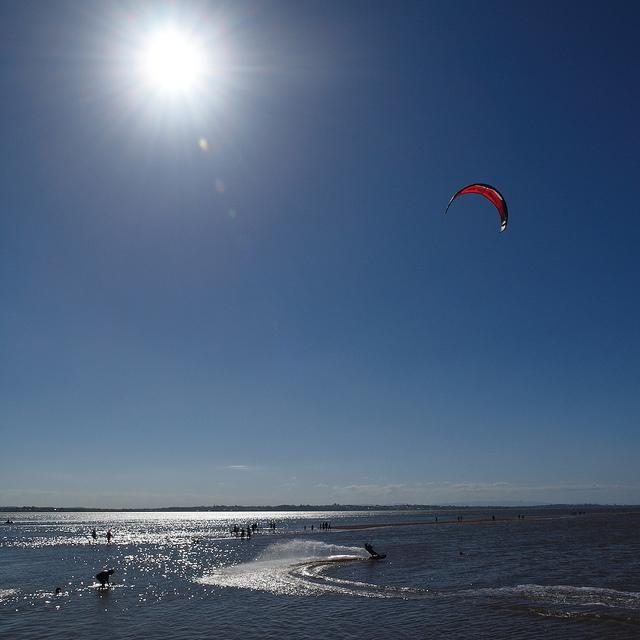What is the person with the kite doing? flying 